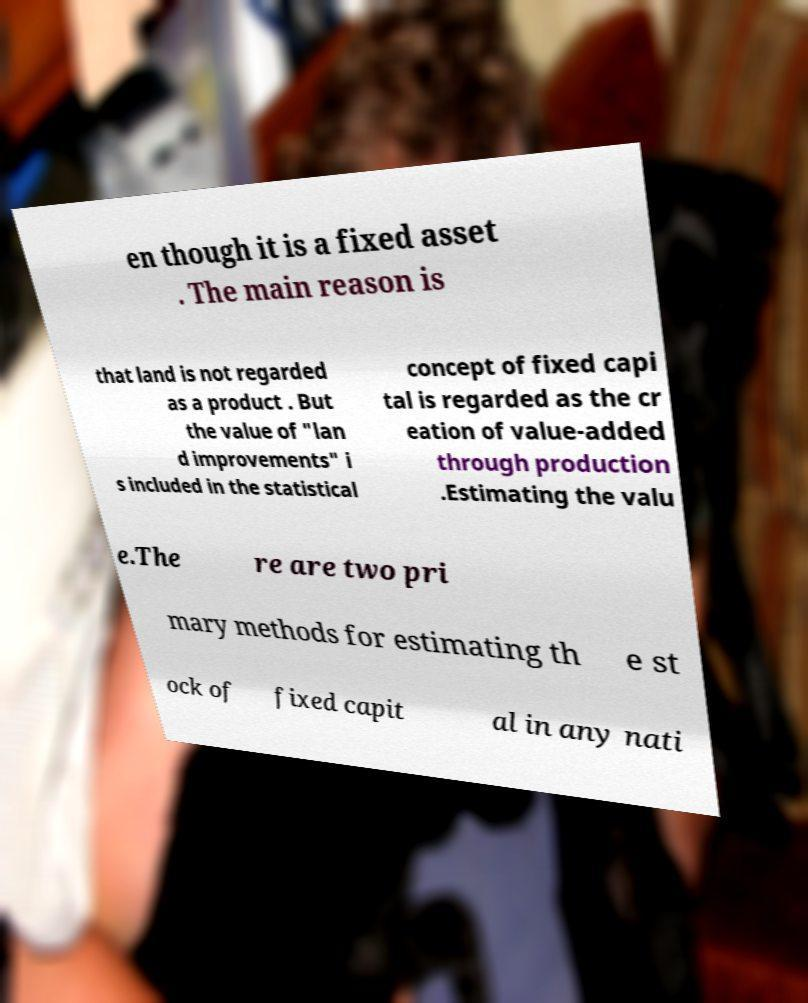Please read and relay the text visible in this image. What does it say? en though it is a fixed asset . The main reason is that land is not regarded as a product . But the value of "lan d improvements" i s included in the statistical concept of fixed capi tal is regarded as the cr eation of value-added through production .Estimating the valu e.The re are two pri mary methods for estimating th e st ock of fixed capit al in any nati 